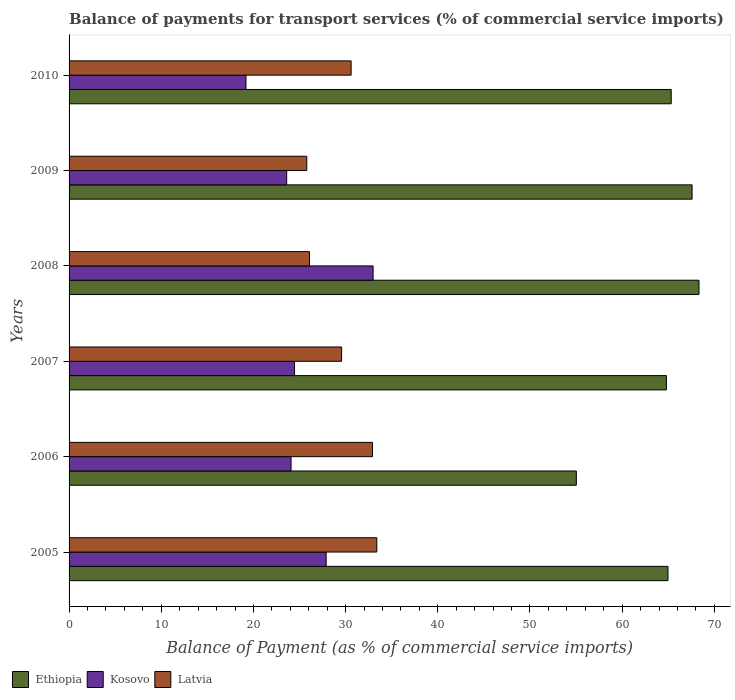How many different coloured bars are there?
Your response must be concise. 3. How many groups of bars are there?
Offer a terse response. 6. Are the number of bars per tick equal to the number of legend labels?
Ensure brevity in your answer.  Yes. Are the number of bars on each tick of the Y-axis equal?
Make the answer very short. Yes. How many bars are there on the 1st tick from the top?
Provide a short and direct response. 3. What is the label of the 3rd group of bars from the top?
Keep it short and to the point. 2008. What is the balance of payments for transport services in Latvia in 2010?
Your answer should be compact. 30.6. Across all years, what is the maximum balance of payments for transport services in Kosovo?
Your answer should be very brief. 32.98. Across all years, what is the minimum balance of payments for transport services in Latvia?
Provide a short and direct response. 25.79. In which year was the balance of payments for transport services in Ethiopia minimum?
Provide a short and direct response. 2006. What is the total balance of payments for transport services in Kosovo in the graph?
Offer a very short reply. 152.2. What is the difference between the balance of payments for transport services in Kosovo in 2007 and that in 2009?
Offer a very short reply. 0.85. What is the difference between the balance of payments for transport services in Kosovo in 2008 and the balance of payments for transport services in Latvia in 2007?
Offer a very short reply. 3.42. What is the average balance of payments for transport services in Kosovo per year?
Provide a succinct answer. 25.37. In the year 2010, what is the difference between the balance of payments for transport services in Kosovo and balance of payments for transport services in Latvia?
Make the answer very short. -11.41. In how many years, is the balance of payments for transport services in Ethiopia greater than 26 %?
Your answer should be very brief. 6. What is the ratio of the balance of payments for transport services in Ethiopia in 2007 to that in 2009?
Your answer should be very brief. 0.96. What is the difference between the highest and the second highest balance of payments for transport services in Kosovo?
Offer a very short reply. 5.09. What is the difference between the highest and the lowest balance of payments for transport services in Kosovo?
Your answer should be compact. 13.79. In how many years, is the balance of payments for transport services in Ethiopia greater than the average balance of payments for transport services in Ethiopia taken over all years?
Provide a short and direct response. 5. What does the 3rd bar from the top in 2010 represents?
Make the answer very short. Ethiopia. What does the 2nd bar from the bottom in 2005 represents?
Give a very brief answer. Kosovo. How many bars are there?
Offer a very short reply. 18. How many years are there in the graph?
Your answer should be compact. 6. Are the values on the major ticks of X-axis written in scientific E-notation?
Ensure brevity in your answer.  No. Does the graph contain grids?
Make the answer very short. No. Where does the legend appear in the graph?
Your answer should be very brief. Bottom left. How many legend labels are there?
Give a very brief answer. 3. What is the title of the graph?
Your answer should be very brief. Balance of payments for transport services (% of commercial service imports). What is the label or title of the X-axis?
Your answer should be compact. Balance of Payment (as % of commercial service imports). What is the Balance of Payment (as % of commercial service imports) of Ethiopia in 2005?
Your answer should be compact. 64.97. What is the Balance of Payment (as % of commercial service imports) in Kosovo in 2005?
Provide a short and direct response. 27.89. What is the Balance of Payment (as % of commercial service imports) in Latvia in 2005?
Offer a terse response. 33.38. What is the Balance of Payment (as % of commercial service imports) of Ethiopia in 2006?
Make the answer very short. 55.03. What is the Balance of Payment (as % of commercial service imports) in Kosovo in 2006?
Provide a short and direct response. 24.08. What is the Balance of Payment (as % of commercial service imports) in Latvia in 2006?
Your response must be concise. 32.92. What is the Balance of Payment (as % of commercial service imports) of Ethiopia in 2007?
Your response must be concise. 64.8. What is the Balance of Payment (as % of commercial service imports) in Kosovo in 2007?
Your response must be concise. 24.46. What is the Balance of Payment (as % of commercial service imports) in Latvia in 2007?
Give a very brief answer. 29.56. What is the Balance of Payment (as % of commercial service imports) of Ethiopia in 2008?
Provide a succinct answer. 68.33. What is the Balance of Payment (as % of commercial service imports) in Kosovo in 2008?
Make the answer very short. 32.98. What is the Balance of Payment (as % of commercial service imports) of Latvia in 2008?
Provide a succinct answer. 26.08. What is the Balance of Payment (as % of commercial service imports) of Ethiopia in 2009?
Your answer should be very brief. 67.58. What is the Balance of Payment (as % of commercial service imports) in Kosovo in 2009?
Your answer should be very brief. 23.61. What is the Balance of Payment (as % of commercial service imports) of Latvia in 2009?
Provide a short and direct response. 25.79. What is the Balance of Payment (as % of commercial service imports) in Ethiopia in 2010?
Your answer should be very brief. 65.32. What is the Balance of Payment (as % of commercial service imports) in Kosovo in 2010?
Offer a very short reply. 19.19. What is the Balance of Payment (as % of commercial service imports) of Latvia in 2010?
Offer a very short reply. 30.6. Across all years, what is the maximum Balance of Payment (as % of commercial service imports) of Ethiopia?
Offer a terse response. 68.33. Across all years, what is the maximum Balance of Payment (as % of commercial service imports) of Kosovo?
Provide a succinct answer. 32.98. Across all years, what is the maximum Balance of Payment (as % of commercial service imports) in Latvia?
Your answer should be very brief. 33.38. Across all years, what is the minimum Balance of Payment (as % of commercial service imports) in Ethiopia?
Provide a succinct answer. 55.03. Across all years, what is the minimum Balance of Payment (as % of commercial service imports) in Kosovo?
Provide a succinct answer. 19.19. Across all years, what is the minimum Balance of Payment (as % of commercial service imports) in Latvia?
Your answer should be compact. 25.79. What is the total Balance of Payment (as % of commercial service imports) in Ethiopia in the graph?
Give a very brief answer. 386.04. What is the total Balance of Payment (as % of commercial service imports) in Kosovo in the graph?
Make the answer very short. 152.2. What is the total Balance of Payment (as % of commercial service imports) in Latvia in the graph?
Make the answer very short. 178.32. What is the difference between the Balance of Payment (as % of commercial service imports) in Ethiopia in 2005 and that in 2006?
Offer a terse response. 9.94. What is the difference between the Balance of Payment (as % of commercial service imports) of Kosovo in 2005 and that in 2006?
Provide a succinct answer. 3.81. What is the difference between the Balance of Payment (as % of commercial service imports) of Latvia in 2005 and that in 2006?
Keep it short and to the point. 0.46. What is the difference between the Balance of Payment (as % of commercial service imports) in Ethiopia in 2005 and that in 2007?
Your answer should be very brief. 0.17. What is the difference between the Balance of Payment (as % of commercial service imports) in Kosovo in 2005 and that in 2007?
Provide a short and direct response. 3.43. What is the difference between the Balance of Payment (as % of commercial service imports) in Latvia in 2005 and that in 2007?
Your response must be concise. 3.82. What is the difference between the Balance of Payment (as % of commercial service imports) of Ethiopia in 2005 and that in 2008?
Make the answer very short. -3.37. What is the difference between the Balance of Payment (as % of commercial service imports) of Kosovo in 2005 and that in 2008?
Your answer should be very brief. -5.09. What is the difference between the Balance of Payment (as % of commercial service imports) in Latvia in 2005 and that in 2008?
Your answer should be compact. 7.3. What is the difference between the Balance of Payment (as % of commercial service imports) in Ethiopia in 2005 and that in 2009?
Keep it short and to the point. -2.61. What is the difference between the Balance of Payment (as % of commercial service imports) in Kosovo in 2005 and that in 2009?
Your response must be concise. 4.28. What is the difference between the Balance of Payment (as % of commercial service imports) in Latvia in 2005 and that in 2009?
Ensure brevity in your answer.  7.6. What is the difference between the Balance of Payment (as % of commercial service imports) in Ethiopia in 2005 and that in 2010?
Your response must be concise. -0.35. What is the difference between the Balance of Payment (as % of commercial service imports) of Kosovo in 2005 and that in 2010?
Make the answer very short. 8.7. What is the difference between the Balance of Payment (as % of commercial service imports) of Latvia in 2005 and that in 2010?
Provide a succinct answer. 2.79. What is the difference between the Balance of Payment (as % of commercial service imports) of Ethiopia in 2006 and that in 2007?
Your answer should be compact. -9.77. What is the difference between the Balance of Payment (as % of commercial service imports) in Kosovo in 2006 and that in 2007?
Your answer should be very brief. -0.38. What is the difference between the Balance of Payment (as % of commercial service imports) of Latvia in 2006 and that in 2007?
Give a very brief answer. 3.35. What is the difference between the Balance of Payment (as % of commercial service imports) in Ethiopia in 2006 and that in 2008?
Ensure brevity in your answer.  -13.31. What is the difference between the Balance of Payment (as % of commercial service imports) of Kosovo in 2006 and that in 2008?
Your answer should be compact. -8.9. What is the difference between the Balance of Payment (as % of commercial service imports) in Latvia in 2006 and that in 2008?
Keep it short and to the point. 6.84. What is the difference between the Balance of Payment (as % of commercial service imports) in Ethiopia in 2006 and that in 2009?
Offer a very short reply. -12.56. What is the difference between the Balance of Payment (as % of commercial service imports) in Kosovo in 2006 and that in 2009?
Your response must be concise. 0.47. What is the difference between the Balance of Payment (as % of commercial service imports) of Latvia in 2006 and that in 2009?
Your answer should be very brief. 7.13. What is the difference between the Balance of Payment (as % of commercial service imports) in Ethiopia in 2006 and that in 2010?
Ensure brevity in your answer.  -10.29. What is the difference between the Balance of Payment (as % of commercial service imports) of Kosovo in 2006 and that in 2010?
Your answer should be compact. 4.89. What is the difference between the Balance of Payment (as % of commercial service imports) of Latvia in 2006 and that in 2010?
Provide a succinct answer. 2.32. What is the difference between the Balance of Payment (as % of commercial service imports) of Ethiopia in 2007 and that in 2008?
Keep it short and to the point. -3.53. What is the difference between the Balance of Payment (as % of commercial service imports) in Kosovo in 2007 and that in 2008?
Offer a very short reply. -8.52. What is the difference between the Balance of Payment (as % of commercial service imports) of Latvia in 2007 and that in 2008?
Your answer should be compact. 3.49. What is the difference between the Balance of Payment (as % of commercial service imports) of Ethiopia in 2007 and that in 2009?
Your answer should be compact. -2.78. What is the difference between the Balance of Payment (as % of commercial service imports) of Kosovo in 2007 and that in 2009?
Your response must be concise. 0.85. What is the difference between the Balance of Payment (as % of commercial service imports) in Latvia in 2007 and that in 2009?
Your answer should be compact. 3.78. What is the difference between the Balance of Payment (as % of commercial service imports) in Ethiopia in 2007 and that in 2010?
Make the answer very short. -0.52. What is the difference between the Balance of Payment (as % of commercial service imports) of Kosovo in 2007 and that in 2010?
Your answer should be very brief. 5.27. What is the difference between the Balance of Payment (as % of commercial service imports) of Latvia in 2007 and that in 2010?
Your answer should be compact. -1.03. What is the difference between the Balance of Payment (as % of commercial service imports) of Ethiopia in 2008 and that in 2009?
Ensure brevity in your answer.  0.75. What is the difference between the Balance of Payment (as % of commercial service imports) of Kosovo in 2008 and that in 2009?
Provide a short and direct response. 9.37. What is the difference between the Balance of Payment (as % of commercial service imports) of Latvia in 2008 and that in 2009?
Make the answer very short. 0.29. What is the difference between the Balance of Payment (as % of commercial service imports) of Ethiopia in 2008 and that in 2010?
Your answer should be compact. 3.02. What is the difference between the Balance of Payment (as % of commercial service imports) of Kosovo in 2008 and that in 2010?
Provide a short and direct response. 13.79. What is the difference between the Balance of Payment (as % of commercial service imports) of Latvia in 2008 and that in 2010?
Provide a succinct answer. -4.52. What is the difference between the Balance of Payment (as % of commercial service imports) of Ethiopia in 2009 and that in 2010?
Make the answer very short. 2.26. What is the difference between the Balance of Payment (as % of commercial service imports) of Kosovo in 2009 and that in 2010?
Give a very brief answer. 4.42. What is the difference between the Balance of Payment (as % of commercial service imports) of Latvia in 2009 and that in 2010?
Give a very brief answer. -4.81. What is the difference between the Balance of Payment (as % of commercial service imports) of Ethiopia in 2005 and the Balance of Payment (as % of commercial service imports) of Kosovo in 2006?
Your answer should be very brief. 40.89. What is the difference between the Balance of Payment (as % of commercial service imports) in Ethiopia in 2005 and the Balance of Payment (as % of commercial service imports) in Latvia in 2006?
Give a very brief answer. 32.05. What is the difference between the Balance of Payment (as % of commercial service imports) in Kosovo in 2005 and the Balance of Payment (as % of commercial service imports) in Latvia in 2006?
Provide a short and direct response. -5.03. What is the difference between the Balance of Payment (as % of commercial service imports) of Ethiopia in 2005 and the Balance of Payment (as % of commercial service imports) of Kosovo in 2007?
Offer a terse response. 40.51. What is the difference between the Balance of Payment (as % of commercial service imports) of Ethiopia in 2005 and the Balance of Payment (as % of commercial service imports) of Latvia in 2007?
Your response must be concise. 35.41. What is the difference between the Balance of Payment (as % of commercial service imports) in Kosovo in 2005 and the Balance of Payment (as % of commercial service imports) in Latvia in 2007?
Your response must be concise. -1.68. What is the difference between the Balance of Payment (as % of commercial service imports) of Ethiopia in 2005 and the Balance of Payment (as % of commercial service imports) of Kosovo in 2008?
Provide a short and direct response. 31.99. What is the difference between the Balance of Payment (as % of commercial service imports) of Ethiopia in 2005 and the Balance of Payment (as % of commercial service imports) of Latvia in 2008?
Your response must be concise. 38.89. What is the difference between the Balance of Payment (as % of commercial service imports) in Kosovo in 2005 and the Balance of Payment (as % of commercial service imports) in Latvia in 2008?
Offer a terse response. 1.81. What is the difference between the Balance of Payment (as % of commercial service imports) in Ethiopia in 2005 and the Balance of Payment (as % of commercial service imports) in Kosovo in 2009?
Offer a very short reply. 41.36. What is the difference between the Balance of Payment (as % of commercial service imports) of Ethiopia in 2005 and the Balance of Payment (as % of commercial service imports) of Latvia in 2009?
Ensure brevity in your answer.  39.18. What is the difference between the Balance of Payment (as % of commercial service imports) in Kosovo in 2005 and the Balance of Payment (as % of commercial service imports) in Latvia in 2009?
Give a very brief answer. 2.1. What is the difference between the Balance of Payment (as % of commercial service imports) of Ethiopia in 2005 and the Balance of Payment (as % of commercial service imports) of Kosovo in 2010?
Offer a terse response. 45.78. What is the difference between the Balance of Payment (as % of commercial service imports) in Ethiopia in 2005 and the Balance of Payment (as % of commercial service imports) in Latvia in 2010?
Offer a very short reply. 34.37. What is the difference between the Balance of Payment (as % of commercial service imports) of Kosovo in 2005 and the Balance of Payment (as % of commercial service imports) of Latvia in 2010?
Make the answer very short. -2.71. What is the difference between the Balance of Payment (as % of commercial service imports) of Ethiopia in 2006 and the Balance of Payment (as % of commercial service imports) of Kosovo in 2007?
Keep it short and to the point. 30.57. What is the difference between the Balance of Payment (as % of commercial service imports) of Ethiopia in 2006 and the Balance of Payment (as % of commercial service imports) of Latvia in 2007?
Your answer should be very brief. 25.46. What is the difference between the Balance of Payment (as % of commercial service imports) of Kosovo in 2006 and the Balance of Payment (as % of commercial service imports) of Latvia in 2007?
Offer a very short reply. -5.48. What is the difference between the Balance of Payment (as % of commercial service imports) in Ethiopia in 2006 and the Balance of Payment (as % of commercial service imports) in Kosovo in 2008?
Your answer should be compact. 22.05. What is the difference between the Balance of Payment (as % of commercial service imports) in Ethiopia in 2006 and the Balance of Payment (as % of commercial service imports) in Latvia in 2008?
Ensure brevity in your answer.  28.95. What is the difference between the Balance of Payment (as % of commercial service imports) of Kosovo in 2006 and the Balance of Payment (as % of commercial service imports) of Latvia in 2008?
Make the answer very short. -2. What is the difference between the Balance of Payment (as % of commercial service imports) in Ethiopia in 2006 and the Balance of Payment (as % of commercial service imports) in Kosovo in 2009?
Provide a short and direct response. 31.42. What is the difference between the Balance of Payment (as % of commercial service imports) in Ethiopia in 2006 and the Balance of Payment (as % of commercial service imports) in Latvia in 2009?
Give a very brief answer. 29.24. What is the difference between the Balance of Payment (as % of commercial service imports) in Kosovo in 2006 and the Balance of Payment (as % of commercial service imports) in Latvia in 2009?
Your response must be concise. -1.71. What is the difference between the Balance of Payment (as % of commercial service imports) of Ethiopia in 2006 and the Balance of Payment (as % of commercial service imports) of Kosovo in 2010?
Offer a terse response. 35.84. What is the difference between the Balance of Payment (as % of commercial service imports) in Ethiopia in 2006 and the Balance of Payment (as % of commercial service imports) in Latvia in 2010?
Provide a short and direct response. 24.43. What is the difference between the Balance of Payment (as % of commercial service imports) in Kosovo in 2006 and the Balance of Payment (as % of commercial service imports) in Latvia in 2010?
Provide a succinct answer. -6.52. What is the difference between the Balance of Payment (as % of commercial service imports) in Ethiopia in 2007 and the Balance of Payment (as % of commercial service imports) in Kosovo in 2008?
Offer a very short reply. 31.82. What is the difference between the Balance of Payment (as % of commercial service imports) in Ethiopia in 2007 and the Balance of Payment (as % of commercial service imports) in Latvia in 2008?
Your answer should be very brief. 38.72. What is the difference between the Balance of Payment (as % of commercial service imports) in Kosovo in 2007 and the Balance of Payment (as % of commercial service imports) in Latvia in 2008?
Your response must be concise. -1.62. What is the difference between the Balance of Payment (as % of commercial service imports) of Ethiopia in 2007 and the Balance of Payment (as % of commercial service imports) of Kosovo in 2009?
Offer a very short reply. 41.19. What is the difference between the Balance of Payment (as % of commercial service imports) of Ethiopia in 2007 and the Balance of Payment (as % of commercial service imports) of Latvia in 2009?
Offer a terse response. 39.02. What is the difference between the Balance of Payment (as % of commercial service imports) of Kosovo in 2007 and the Balance of Payment (as % of commercial service imports) of Latvia in 2009?
Your answer should be compact. -1.33. What is the difference between the Balance of Payment (as % of commercial service imports) in Ethiopia in 2007 and the Balance of Payment (as % of commercial service imports) in Kosovo in 2010?
Offer a terse response. 45.61. What is the difference between the Balance of Payment (as % of commercial service imports) in Ethiopia in 2007 and the Balance of Payment (as % of commercial service imports) in Latvia in 2010?
Your answer should be compact. 34.21. What is the difference between the Balance of Payment (as % of commercial service imports) of Kosovo in 2007 and the Balance of Payment (as % of commercial service imports) of Latvia in 2010?
Your answer should be compact. -6.14. What is the difference between the Balance of Payment (as % of commercial service imports) in Ethiopia in 2008 and the Balance of Payment (as % of commercial service imports) in Kosovo in 2009?
Your response must be concise. 44.73. What is the difference between the Balance of Payment (as % of commercial service imports) of Ethiopia in 2008 and the Balance of Payment (as % of commercial service imports) of Latvia in 2009?
Keep it short and to the point. 42.55. What is the difference between the Balance of Payment (as % of commercial service imports) of Kosovo in 2008 and the Balance of Payment (as % of commercial service imports) of Latvia in 2009?
Offer a terse response. 7.19. What is the difference between the Balance of Payment (as % of commercial service imports) of Ethiopia in 2008 and the Balance of Payment (as % of commercial service imports) of Kosovo in 2010?
Provide a succinct answer. 49.15. What is the difference between the Balance of Payment (as % of commercial service imports) in Ethiopia in 2008 and the Balance of Payment (as % of commercial service imports) in Latvia in 2010?
Keep it short and to the point. 37.74. What is the difference between the Balance of Payment (as % of commercial service imports) in Kosovo in 2008 and the Balance of Payment (as % of commercial service imports) in Latvia in 2010?
Your response must be concise. 2.38. What is the difference between the Balance of Payment (as % of commercial service imports) of Ethiopia in 2009 and the Balance of Payment (as % of commercial service imports) of Kosovo in 2010?
Give a very brief answer. 48.39. What is the difference between the Balance of Payment (as % of commercial service imports) of Ethiopia in 2009 and the Balance of Payment (as % of commercial service imports) of Latvia in 2010?
Give a very brief answer. 36.99. What is the difference between the Balance of Payment (as % of commercial service imports) in Kosovo in 2009 and the Balance of Payment (as % of commercial service imports) in Latvia in 2010?
Your response must be concise. -6.99. What is the average Balance of Payment (as % of commercial service imports) of Ethiopia per year?
Offer a very short reply. 64.34. What is the average Balance of Payment (as % of commercial service imports) in Kosovo per year?
Make the answer very short. 25.37. What is the average Balance of Payment (as % of commercial service imports) of Latvia per year?
Make the answer very short. 29.72. In the year 2005, what is the difference between the Balance of Payment (as % of commercial service imports) of Ethiopia and Balance of Payment (as % of commercial service imports) of Kosovo?
Provide a succinct answer. 37.08. In the year 2005, what is the difference between the Balance of Payment (as % of commercial service imports) in Ethiopia and Balance of Payment (as % of commercial service imports) in Latvia?
Offer a very short reply. 31.59. In the year 2005, what is the difference between the Balance of Payment (as % of commercial service imports) in Kosovo and Balance of Payment (as % of commercial service imports) in Latvia?
Your response must be concise. -5.49. In the year 2006, what is the difference between the Balance of Payment (as % of commercial service imports) in Ethiopia and Balance of Payment (as % of commercial service imports) in Kosovo?
Give a very brief answer. 30.95. In the year 2006, what is the difference between the Balance of Payment (as % of commercial service imports) of Ethiopia and Balance of Payment (as % of commercial service imports) of Latvia?
Offer a very short reply. 22.11. In the year 2006, what is the difference between the Balance of Payment (as % of commercial service imports) of Kosovo and Balance of Payment (as % of commercial service imports) of Latvia?
Keep it short and to the point. -8.84. In the year 2007, what is the difference between the Balance of Payment (as % of commercial service imports) in Ethiopia and Balance of Payment (as % of commercial service imports) in Kosovo?
Give a very brief answer. 40.34. In the year 2007, what is the difference between the Balance of Payment (as % of commercial service imports) in Ethiopia and Balance of Payment (as % of commercial service imports) in Latvia?
Your answer should be compact. 35.24. In the year 2007, what is the difference between the Balance of Payment (as % of commercial service imports) of Kosovo and Balance of Payment (as % of commercial service imports) of Latvia?
Provide a succinct answer. -5.11. In the year 2008, what is the difference between the Balance of Payment (as % of commercial service imports) of Ethiopia and Balance of Payment (as % of commercial service imports) of Kosovo?
Ensure brevity in your answer.  35.35. In the year 2008, what is the difference between the Balance of Payment (as % of commercial service imports) of Ethiopia and Balance of Payment (as % of commercial service imports) of Latvia?
Provide a short and direct response. 42.26. In the year 2008, what is the difference between the Balance of Payment (as % of commercial service imports) in Kosovo and Balance of Payment (as % of commercial service imports) in Latvia?
Ensure brevity in your answer.  6.9. In the year 2009, what is the difference between the Balance of Payment (as % of commercial service imports) in Ethiopia and Balance of Payment (as % of commercial service imports) in Kosovo?
Offer a terse response. 43.98. In the year 2009, what is the difference between the Balance of Payment (as % of commercial service imports) in Ethiopia and Balance of Payment (as % of commercial service imports) in Latvia?
Your answer should be very brief. 41.8. In the year 2009, what is the difference between the Balance of Payment (as % of commercial service imports) of Kosovo and Balance of Payment (as % of commercial service imports) of Latvia?
Offer a very short reply. -2.18. In the year 2010, what is the difference between the Balance of Payment (as % of commercial service imports) in Ethiopia and Balance of Payment (as % of commercial service imports) in Kosovo?
Offer a terse response. 46.13. In the year 2010, what is the difference between the Balance of Payment (as % of commercial service imports) of Ethiopia and Balance of Payment (as % of commercial service imports) of Latvia?
Ensure brevity in your answer.  34.72. In the year 2010, what is the difference between the Balance of Payment (as % of commercial service imports) in Kosovo and Balance of Payment (as % of commercial service imports) in Latvia?
Your answer should be compact. -11.41. What is the ratio of the Balance of Payment (as % of commercial service imports) of Ethiopia in 2005 to that in 2006?
Ensure brevity in your answer.  1.18. What is the ratio of the Balance of Payment (as % of commercial service imports) of Kosovo in 2005 to that in 2006?
Offer a very short reply. 1.16. What is the ratio of the Balance of Payment (as % of commercial service imports) in Latvia in 2005 to that in 2006?
Offer a very short reply. 1.01. What is the ratio of the Balance of Payment (as % of commercial service imports) in Ethiopia in 2005 to that in 2007?
Provide a succinct answer. 1. What is the ratio of the Balance of Payment (as % of commercial service imports) in Kosovo in 2005 to that in 2007?
Your answer should be very brief. 1.14. What is the ratio of the Balance of Payment (as % of commercial service imports) of Latvia in 2005 to that in 2007?
Your answer should be very brief. 1.13. What is the ratio of the Balance of Payment (as % of commercial service imports) of Ethiopia in 2005 to that in 2008?
Your answer should be very brief. 0.95. What is the ratio of the Balance of Payment (as % of commercial service imports) in Kosovo in 2005 to that in 2008?
Provide a succinct answer. 0.85. What is the ratio of the Balance of Payment (as % of commercial service imports) in Latvia in 2005 to that in 2008?
Provide a succinct answer. 1.28. What is the ratio of the Balance of Payment (as % of commercial service imports) of Ethiopia in 2005 to that in 2009?
Offer a terse response. 0.96. What is the ratio of the Balance of Payment (as % of commercial service imports) of Kosovo in 2005 to that in 2009?
Provide a short and direct response. 1.18. What is the ratio of the Balance of Payment (as % of commercial service imports) of Latvia in 2005 to that in 2009?
Offer a very short reply. 1.29. What is the ratio of the Balance of Payment (as % of commercial service imports) in Ethiopia in 2005 to that in 2010?
Offer a very short reply. 0.99. What is the ratio of the Balance of Payment (as % of commercial service imports) in Kosovo in 2005 to that in 2010?
Offer a very short reply. 1.45. What is the ratio of the Balance of Payment (as % of commercial service imports) of Latvia in 2005 to that in 2010?
Offer a terse response. 1.09. What is the ratio of the Balance of Payment (as % of commercial service imports) in Ethiopia in 2006 to that in 2007?
Give a very brief answer. 0.85. What is the ratio of the Balance of Payment (as % of commercial service imports) in Kosovo in 2006 to that in 2007?
Offer a terse response. 0.98. What is the ratio of the Balance of Payment (as % of commercial service imports) of Latvia in 2006 to that in 2007?
Give a very brief answer. 1.11. What is the ratio of the Balance of Payment (as % of commercial service imports) of Ethiopia in 2006 to that in 2008?
Your answer should be compact. 0.81. What is the ratio of the Balance of Payment (as % of commercial service imports) in Kosovo in 2006 to that in 2008?
Your answer should be very brief. 0.73. What is the ratio of the Balance of Payment (as % of commercial service imports) in Latvia in 2006 to that in 2008?
Your answer should be compact. 1.26. What is the ratio of the Balance of Payment (as % of commercial service imports) of Ethiopia in 2006 to that in 2009?
Make the answer very short. 0.81. What is the ratio of the Balance of Payment (as % of commercial service imports) of Latvia in 2006 to that in 2009?
Offer a terse response. 1.28. What is the ratio of the Balance of Payment (as % of commercial service imports) in Ethiopia in 2006 to that in 2010?
Make the answer very short. 0.84. What is the ratio of the Balance of Payment (as % of commercial service imports) in Kosovo in 2006 to that in 2010?
Give a very brief answer. 1.25. What is the ratio of the Balance of Payment (as % of commercial service imports) in Latvia in 2006 to that in 2010?
Give a very brief answer. 1.08. What is the ratio of the Balance of Payment (as % of commercial service imports) of Ethiopia in 2007 to that in 2008?
Your answer should be very brief. 0.95. What is the ratio of the Balance of Payment (as % of commercial service imports) of Kosovo in 2007 to that in 2008?
Provide a short and direct response. 0.74. What is the ratio of the Balance of Payment (as % of commercial service imports) in Latvia in 2007 to that in 2008?
Your answer should be very brief. 1.13. What is the ratio of the Balance of Payment (as % of commercial service imports) in Ethiopia in 2007 to that in 2009?
Ensure brevity in your answer.  0.96. What is the ratio of the Balance of Payment (as % of commercial service imports) of Kosovo in 2007 to that in 2009?
Provide a short and direct response. 1.04. What is the ratio of the Balance of Payment (as % of commercial service imports) in Latvia in 2007 to that in 2009?
Your response must be concise. 1.15. What is the ratio of the Balance of Payment (as % of commercial service imports) of Kosovo in 2007 to that in 2010?
Give a very brief answer. 1.27. What is the ratio of the Balance of Payment (as % of commercial service imports) in Latvia in 2007 to that in 2010?
Offer a very short reply. 0.97. What is the ratio of the Balance of Payment (as % of commercial service imports) of Ethiopia in 2008 to that in 2009?
Your answer should be very brief. 1.01. What is the ratio of the Balance of Payment (as % of commercial service imports) of Kosovo in 2008 to that in 2009?
Provide a succinct answer. 1.4. What is the ratio of the Balance of Payment (as % of commercial service imports) in Latvia in 2008 to that in 2009?
Offer a very short reply. 1.01. What is the ratio of the Balance of Payment (as % of commercial service imports) in Ethiopia in 2008 to that in 2010?
Make the answer very short. 1.05. What is the ratio of the Balance of Payment (as % of commercial service imports) in Kosovo in 2008 to that in 2010?
Offer a terse response. 1.72. What is the ratio of the Balance of Payment (as % of commercial service imports) in Latvia in 2008 to that in 2010?
Your answer should be compact. 0.85. What is the ratio of the Balance of Payment (as % of commercial service imports) of Ethiopia in 2009 to that in 2010?
Provide a succinct answer. 1.03. What is the ratio of the Balance of Payment (as % of commercial service imports) in Kosovo in 2009 to that in 2010?
Your response must be concise. 1.23. What is the ratio of the Balance of Payment (as % of commercial service imports) in Latvia in 2009 to that in 2010?
Ensure brevity in your answer.  0.84. What is the difference between the highest and the second highest Balance of Payment (as % of commercial service imports) of Ethiopia?
Keep it short and to the point. 0.75. What is the difference between the highest and the second highest Balance of Payment (as % of commercial service imports) of Kosovo?
Keep it short and to the point. 5.09. What is the difference between the highest and the second highest Balance of Payment (as % of commercial service imports) in Latvia?
Ensure brevity in your answer.  0.46. What is the difference between the highest and the lowest Balance of Payment (as % of commercial service imports) of Ethiopia?
Your answer should be very brief. 13.31. What is the difference between the highest and the lowest Balance of Payment (as % of commercial service imports) of Kosovo?
Offer a terse response. 13.79. What is the difference between the highest and the lowest Balance of Payment (as % of commercial service imports) in Latvia?
Make the answer very short. 7.6. 